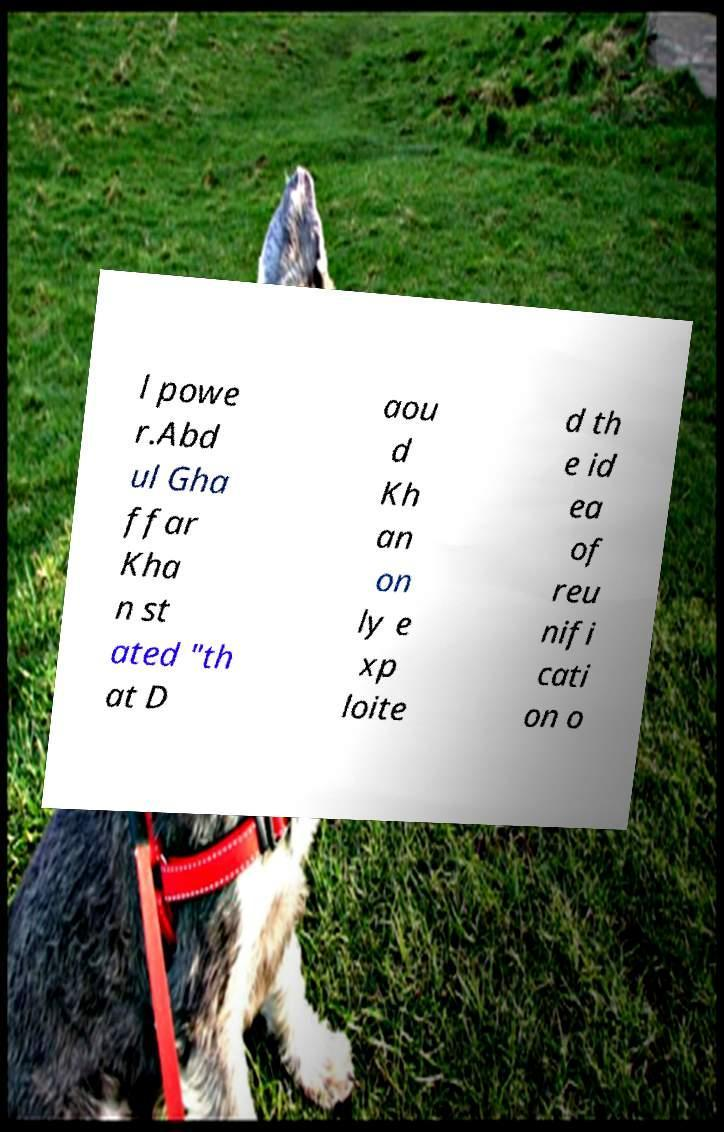There's text embedded in this image that I need extracted. Can you transcribe it verbatim? l powe r.Abd ul Gha ffar Kha n st ated "th at D aou d Kh an on ly e xp loite d th e id ea of reu nifi cati on o 